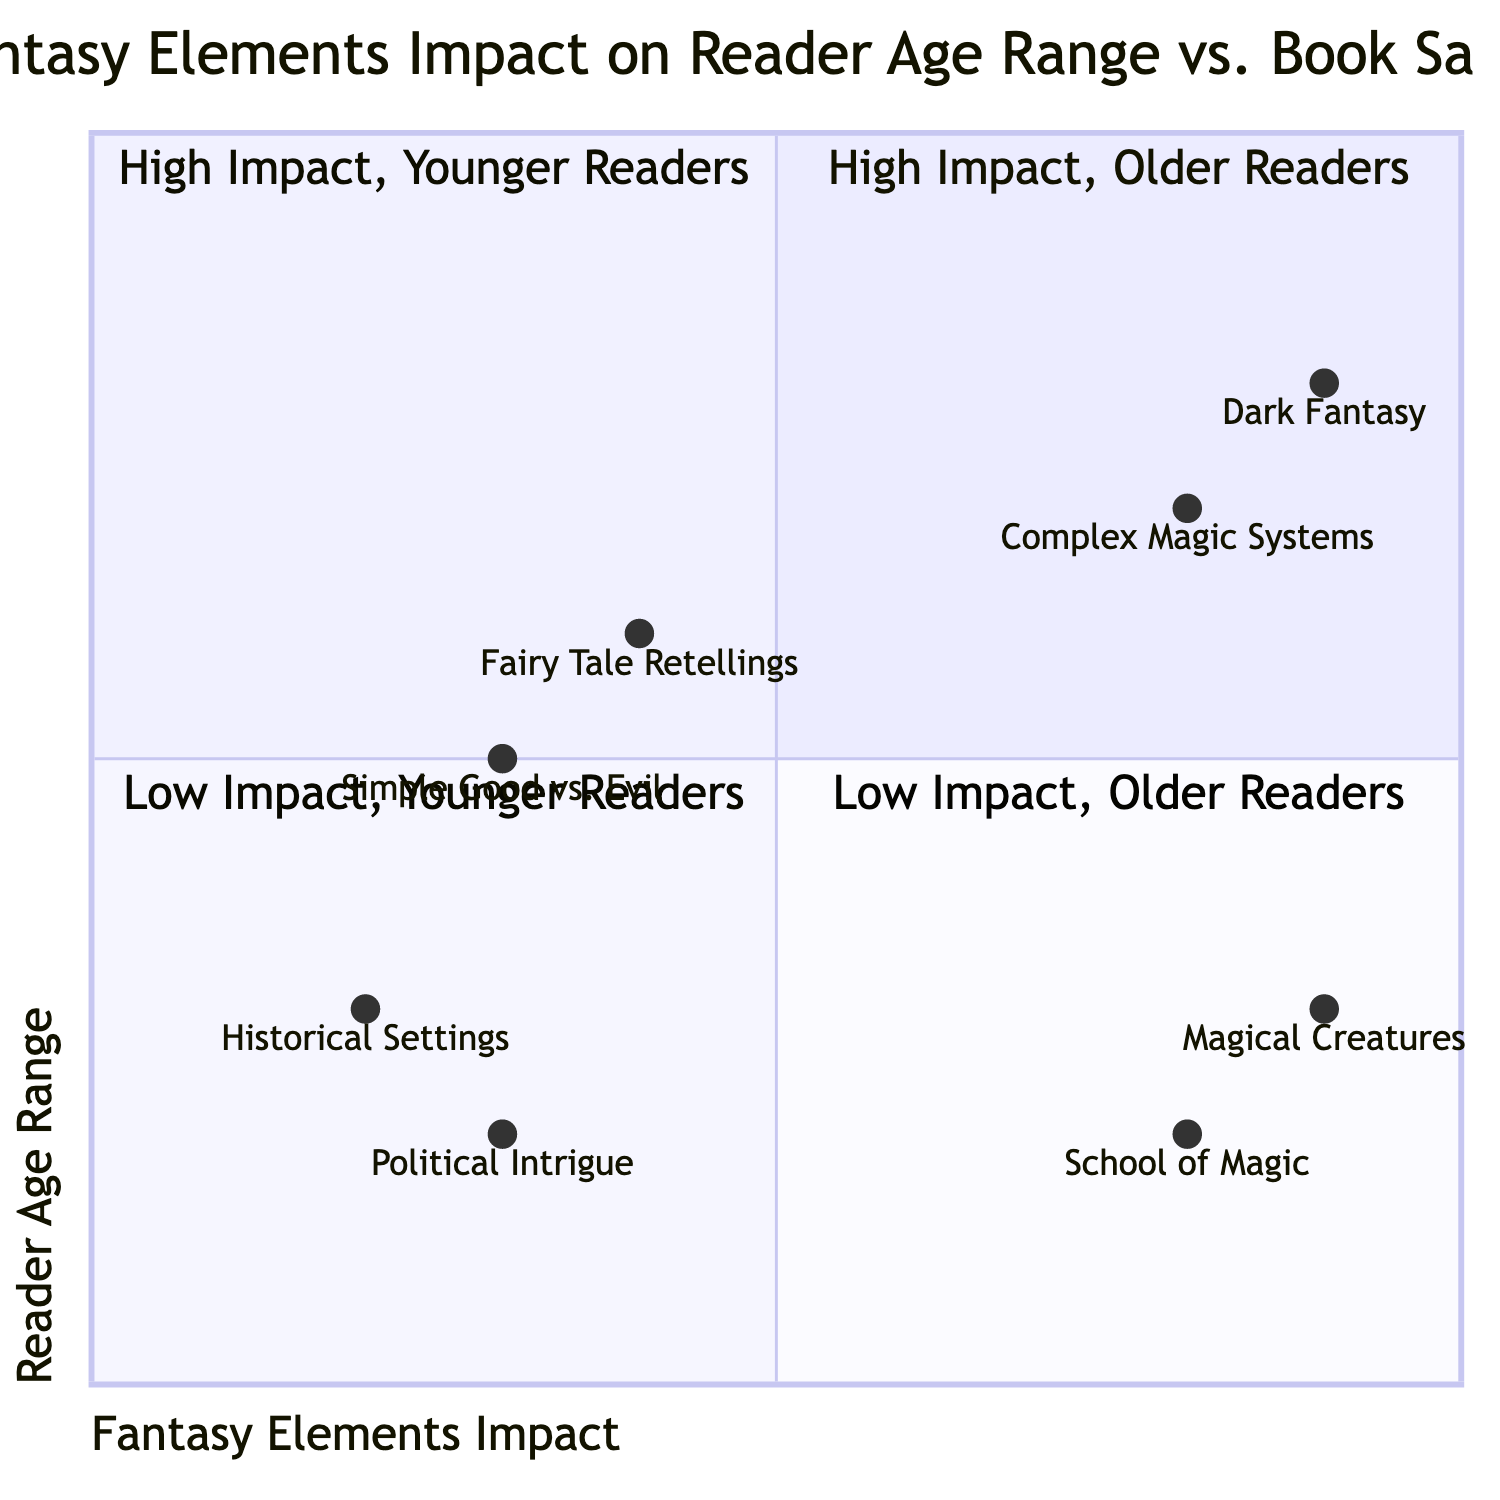What is the element in the "High Impact, Younger Readers" quadrant that features magical creatures? In the "High Impact, Younger Readers" quadrant, the element mentioned is "Magical Creatures", which is specifically referred to as a category that attracts a younger audience.
Answer: Magical Creatures How many examples are listed in the "Low Impact, Older Readers" quadrant? The "Low Impact, Older Readers" quadrant contains two examples, which are "Fairy Tale Retellings" and "Simple Good vs. Evil Plotlines."
Answer: 2 What is the impact of "Dark Fantasy" on reader age range? "Dark Fantasy" is positioned in the "High Impact, Older Readers" quadrant, indicating that it has a significant impact on the older age demographic.
Answer: High Impact Which book examples are associated with "School of Magic"? The "School of Magic" element is linked with the "Harry Potter series", and this connection is specific to the younger demographic in the diagram.
Answer: Harry Potter series Compare the impacts of "Political Intrigue" and "Historical Settings with Little Magic." Which has a higher impact? "Political Intrigue" is categorised in the "Low Impact, Younger Readers" quadrant with a position of [0.3, 0.2], while "Historical Settings with Little Magic" is in the same quadrant, with a slightly higher impact value at [0.2, 0.3], indicating "Political Intrigue" has lower impact than "Historical Settings."
Answer: Historical Settings with Little Magic What reader age range is most associated with "Complex Magic Systems"? "Complex Magic Systems" is found in the "High Impact, Older Readers" quadrant, showing a strong association with the older reader demographic.
Answer: Older Readers What are the main fantasy elements that appeal to the younger demographic? The main fantasy elements that appeal to the younger demographic, according to the diagram, are "Magical Creatures" and "School of Magic," both located in the "High Impact, Younger Readers" quadrant.
Answer: Magical Creatures and School of Magic Which element has the highest impact score in the "High Impact, Older Readers"? The element "Dark Fantasy" has the highest impact score in the "High Impact, Older Readers" quadrant, recorded at [0.9, 0.8].
Answer: Dark Fantasy How do the impacts of "Fairy Tale Retellings" and "Simple Good vs. Evil Plotlines" compare in the "Low Impact, Older Readers" quadrant? In the "Low Impact, Older Readers" quadrant, "Fairy Tale Retellings" scores [0.4, 0.6] while "Simple Good vs. Evil Plotlines" scores [0.3, 0.5]. Thus, "Fairy Tale Retellings" has a higher impact score than "Simple Good vs. Evil Plotlines".
Answer: Fairy Tale Retellings 